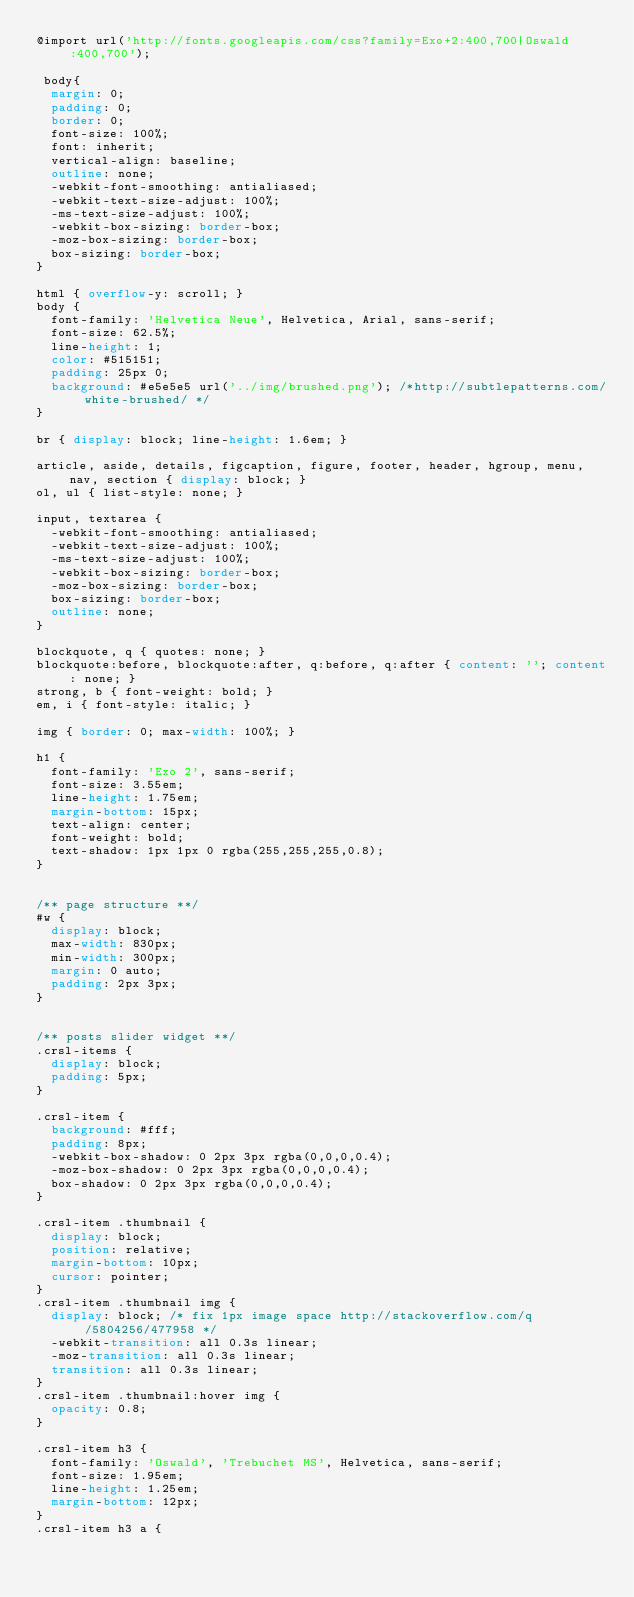Convert code to text. <code><loc_0><loc_0><loc_500><loc_500><_CSS_>@import url('http://fonts.googleapis.com/css?family=Exo+2:400,700|Oswald:400,700');

 body{
  margin: 0;
  padding: 0;
  border: 0;
  font-size: 100%;
  font: inherit;
  vertical-align: baseline;
  outline: none;
  -webkit-font-smoothing: antialiased;
  -webkit-text-size-adjust: 100%;
  -ms-text-size-adjust: 100%;
  -webkit-box-sizing: border-box;
  -moz-box-sizing: border-box;
  box-sizing: border-box;
}

html { overflow-y: scroll; }
body {
  font-family: 'Helvetica Neue', Helvetica, Arial, sans-serif;
  font-size: 62.5%;
  line-height: 1;
  color: #515151;
  padding: 25px 0;
  background: #e5e5e5 url('../img/brushed.png'); /*http://subtlepatterns.com/white-brushed/ */
}

br { display: block; line-height: 1.6em; } 

article, aside, details, figcaption, figure, footer, header, hgroup, menu, nav, section { display: block; }
ol, ul { list-style: none; }

input, textarea { 
  -webkit-font-smoothing: antialiased;
  -webkit-text-size-adjust: 100%;
  -ms-text-size-adjust: 100%;
  -webkit-box-sizing: border-box;
  -moz-box-sizing: border-box;
  box-sizing: border-box;
  outline: none; 
}

blockquote, q { quotes: none; }
blockquote:before, blockquote:after, q:before, q:after { content: ''; content: none; }
strong, b { font-weight: bold; }
em, i { font-style: italic; }

img { border: 0; max-width: 100%; }

h1 {
  font-family: 'Exo 2', sans-serif;
  font-size: 3.55em;
  line-height: 1.75em;
  margin-bottom: 15px;
  text-align: center;
  font-weight: bold;
  text-shadow: 1px 1px 0 rgba(255,255,255,0.8);
}


/** page structure **/
#w {
  display: block;
  max-width: 830px;
  min-width: 300px;
  margin: 0 auto;
  padding: 2px 3px;
}


/** posts slider widget **/
.crsl-items {
  display: block;
  padding: 5px;
}

.crsl-item {
  background: #fff;
  padding: 8px;
  -webkit-box-shadow: 0 2px 3px rgba(0,0,0,0.4);
  -moz-box-shadow: 0 2px 3px rgba(0,0,0,0.4);
  box-shadow: 0 2px 3px rgba(0,0,0,0.4);
}

.crsl-item .thumbnail {
  display: block;
  position: relative;
  margin-bottom: 10px;
  cursor: pointer;
}
.crsl-item .thumbnail img { 
  display: block; /* fix 1px image space http://stackoverflow.com/q/5804256/477958 */
  -webkit-transition: all 0.3s linear;
  -moz-transition: all 0.3s linear;
  transition: all 0.3s linear;
}
.crsl-item .thumbnail:hover img {
  opacity: 0.8;
}

.crsl-item h3 {
  font-family: 'Oswald', 'Trebuchet MS', Helvetica, sans-serif;
  font-size: 1.95em;
  line-height: 1.25em;
  margin-bottom: 12px;
}
.crsl-item h3 a {</code> 